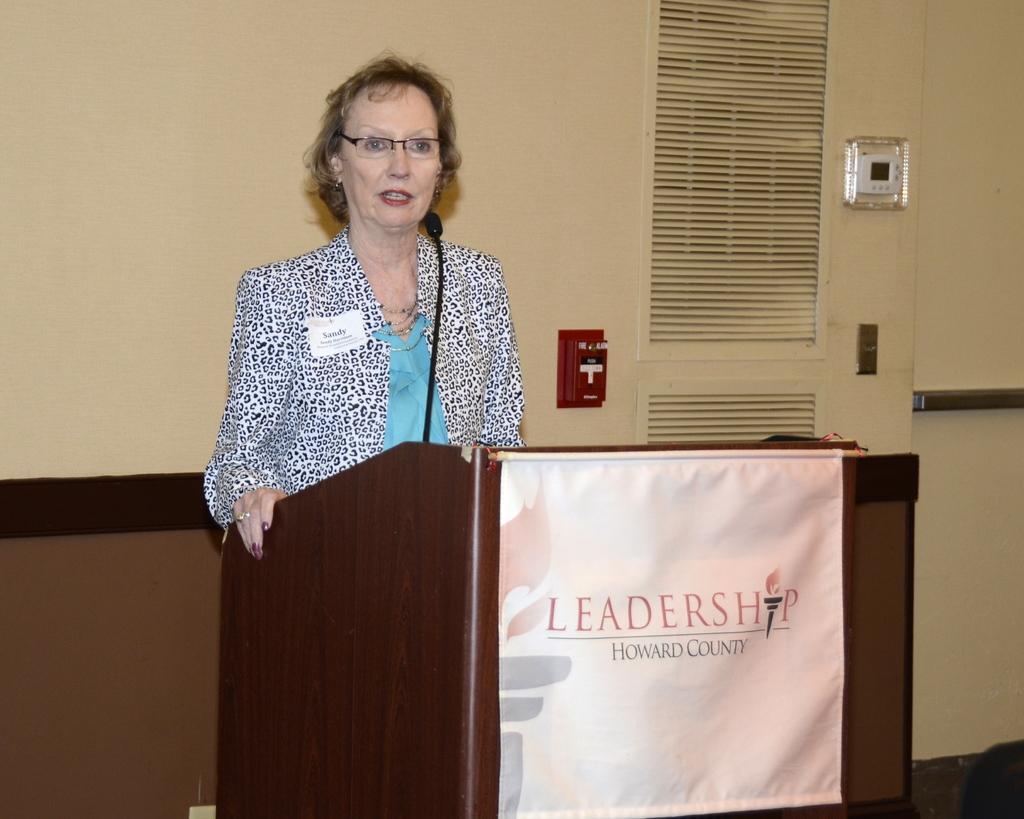How would you summarize this image in a sentence or two? In this image, we can see a woman standing and she is speaking in a microphone, in the background there is a wall. 